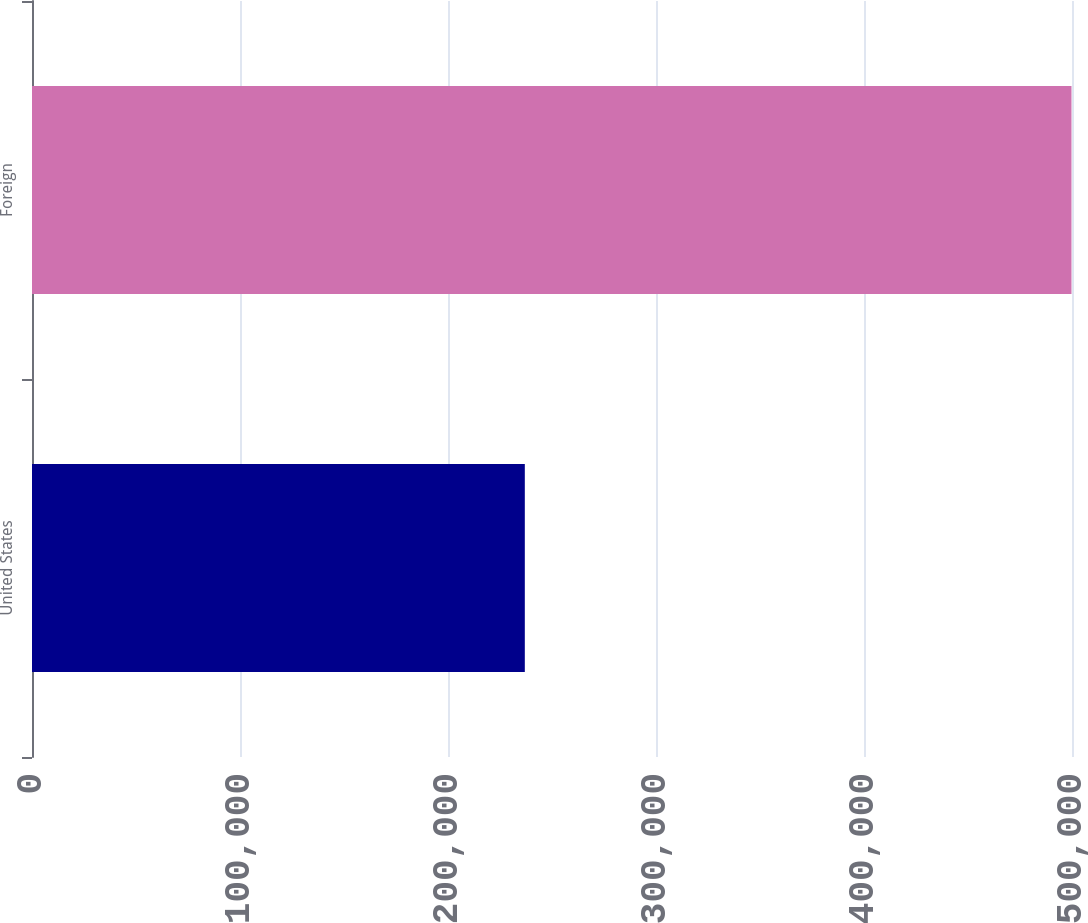Convert chart. <chart><loc_0><loc_0><loc_500><loc_500><bar_chart><fcel>United States<fcel>Foreign<nl><fcel>236932<fcel>499757<nl></chart> 